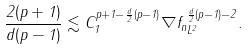Convert formula to latex. <formula><loc_0><loc_0><loc_500><loc_500>\frac { 2 ( p + 1 ) } { d ( p - 1 ) } \lesssim C _ { 1 } ^ { p + 1 - \frac { d } { 2 } ( p - 1 ) } \| \nabla f _ { n } \| _ { L ^ { 2 } } ^ { \frac { d } { 2 } ( p - 1 ) - 2 } .</formula> 